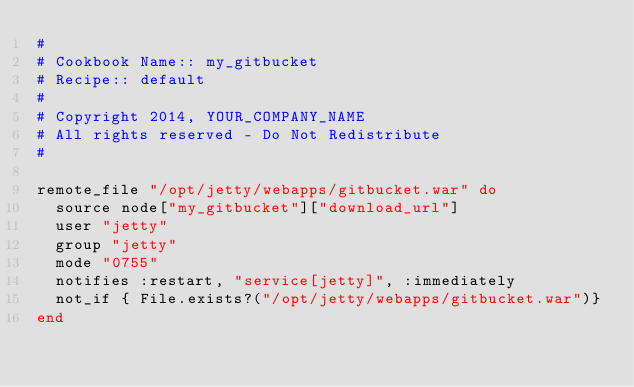Convert code to text. <code><loc_0><loc_0><loc_500><loc_500><_Ruby_>#
# Cookbook Name:: my_gitbucket
# Recipe:: default
#
# Copyright 2014, YOUR_COMPANY_NAME
# All rights reserved - Do Not Redistribute
#

remote_file "/opt/jetty/webapps/gitbucket.war" do
  source node["my_gitbucket"]["download_url"]
  user "jetty"
  group "jetty"
  mode "0755"
  notifies :restart, "service[jetty]", :immediately
  not_if { File.exists?("/opt/jetty/webapps/gitbucket.war")}
end
</code> 